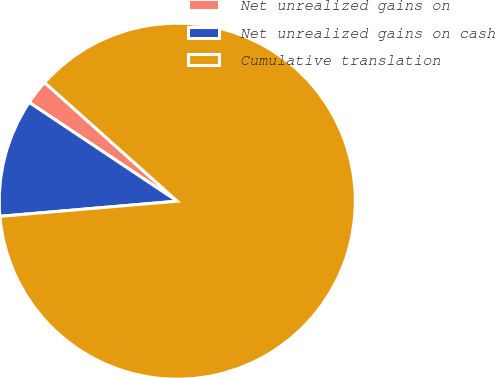Convert chart to OTSL. <chart><loc_0><loc_0><loc_500><loc_500><pie_chart><fcel>Net unrealized gains on<fcel>Net unrealized gains on cash<fcel>Cumulative translation<nl><fcel>2.25%<fcel>10.72%<fcel>87.03%<nl></chart> 